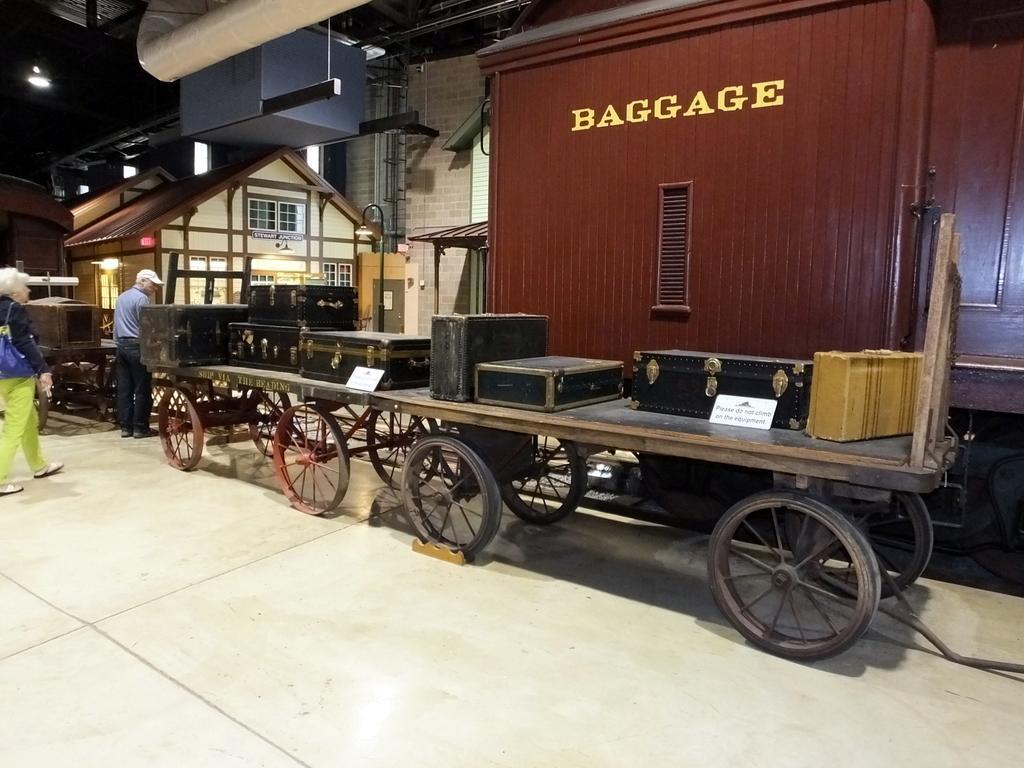In one or two sentences, can you explain what this image depicts? In this picture we can see few suitcases and white boards on the wheel cart. A woman wearing a handbag and is walking on the path on the left side. A man is standing on the path. There is a house and few lights on the top. A wooden object is visible and a building in the background. 